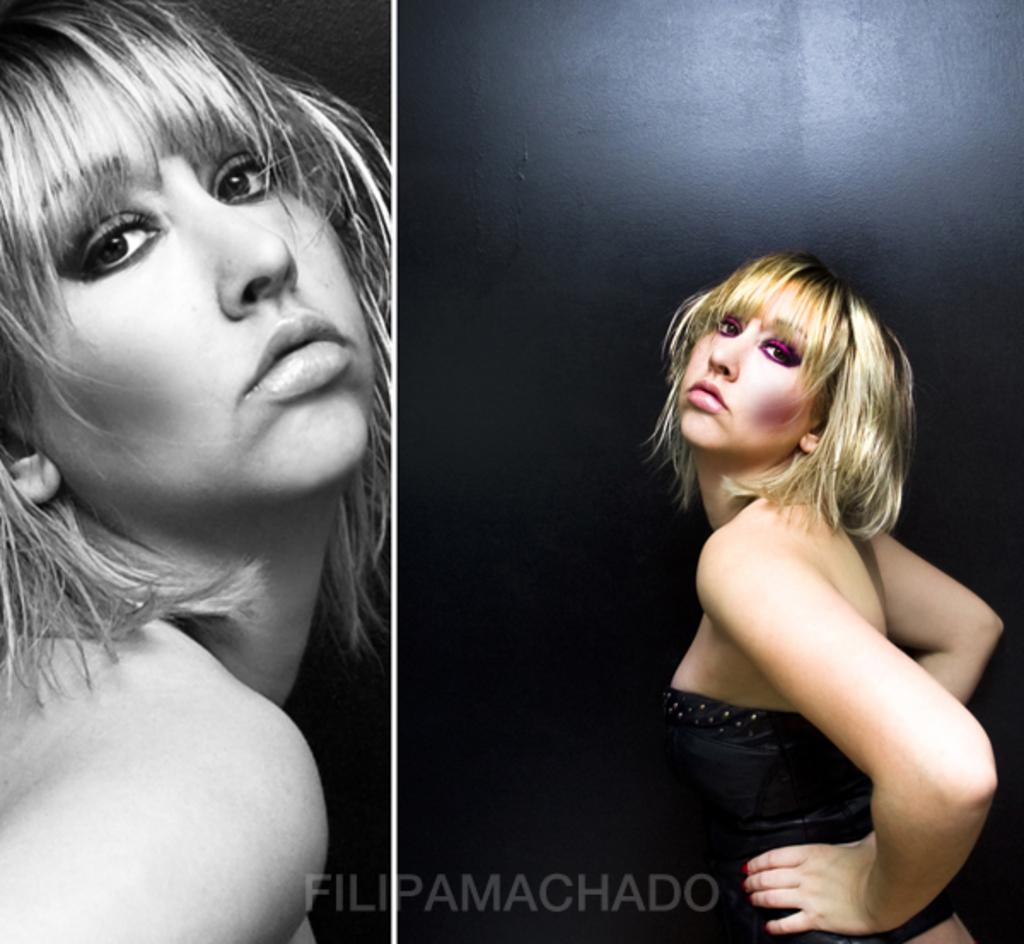What is the main subject of the image? The main subject of the image is a collage of the same person. What is the color of the background in the image? The background of the image is dark. Is there any additional text or marking in the image? Yes, there is a watermark at the bottom of the image. What type of beast can be seen in the image? There is no beast present in the image; it is a collage of the same person. Can you tell me how many cacti are visible in the image? There are no cacti present in the image. 